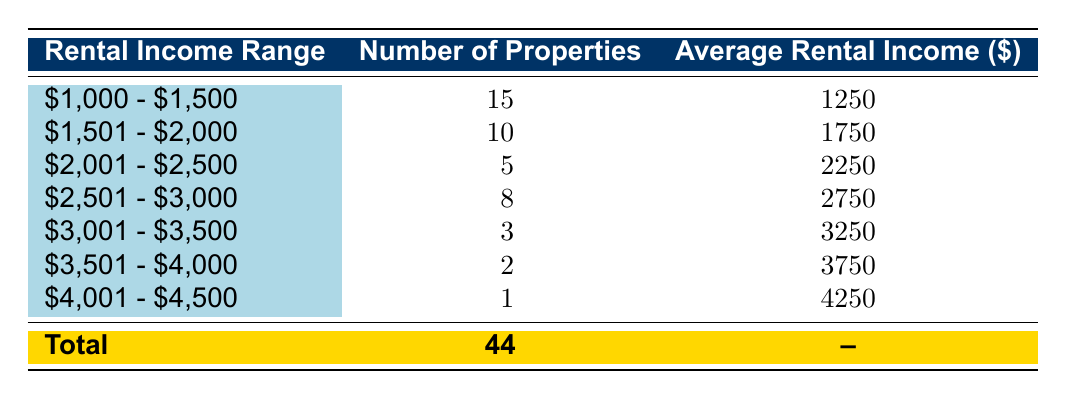What is the rental income range with the highest number of properties? The rental income range with the highest number of properties can be identified by looking at the "Number of Properties" column. The range "$1,000 - $1,500" has 15 properties, which is greater than all other ranges.
Answer: $1,000 - $1,500 How many properties fall within the income range of $2,501 - $3,000? By checking the "Number of Properties" column for the range "$2,501 - $3,000", it shows that there are 8 properties in this range.
Answer: 8 What is the average rental income for the "$3,001 - $3,500" range? The average rental income for the range "$3,001 - $3,500" is found in the corresponding row under the "Average Rental Income" column, which states $3,250.
Answer: $3,250 Are there any rental income ranges with more than 10 properties? We can look at the "Number of Properties" column and observe the values. The only range with more than 10 properties is "$1,000 - $1,500" with 15 properties. Therefore, the answer is yes, there is one such range.
Answer: Yes What is the total number of properties across all rental income ranges? To find the total number of properties, we must sum the values in the "Number of Properties" column: 15 + 10 + 5 + 8 + 3 + 2 + 1 = 44. This total shows that there are 44 properties in total.
Answer: 44 What is the average rental income for all properties combined? To determine the average rental income for all properties, we would normally need the total rental income and the number of properties. However, the average per range can be used with the corresponding number of properties: [(15*1250) + (10*1750) + (5*2250) + (8*2750) + (3*3250) + (2*3750) + (1*4250)] / 44 = $1,902.27 (approximately). This involves multiplying each average by the number of properties, summing them up, and dividing by the total number of properties.
Answer: $1,902.27 Is there any rental income range with a single property? Checking the "Number of Properties" column, the range "$4,001 - $4,500" has only 1 property. This confirms that there is indeed a rental income range with a single property.
Answer: Yes What is the median rental income range based on the number of properties? The median is the middle value when the values are arranged in order. With 7 ranges, the 4th range (once sorted) corresponds to "$2,501 - $3,000", which falls between the 3rd and 4th values based on their order. The total number of properties is 44, and we find that the middle is between ranges $2,001 - $2,500 and $2,501 - $3,000. Therefore, median range is between these two.
Answer: Between $2,001 - $2,500 and $2,501 - $3,000 